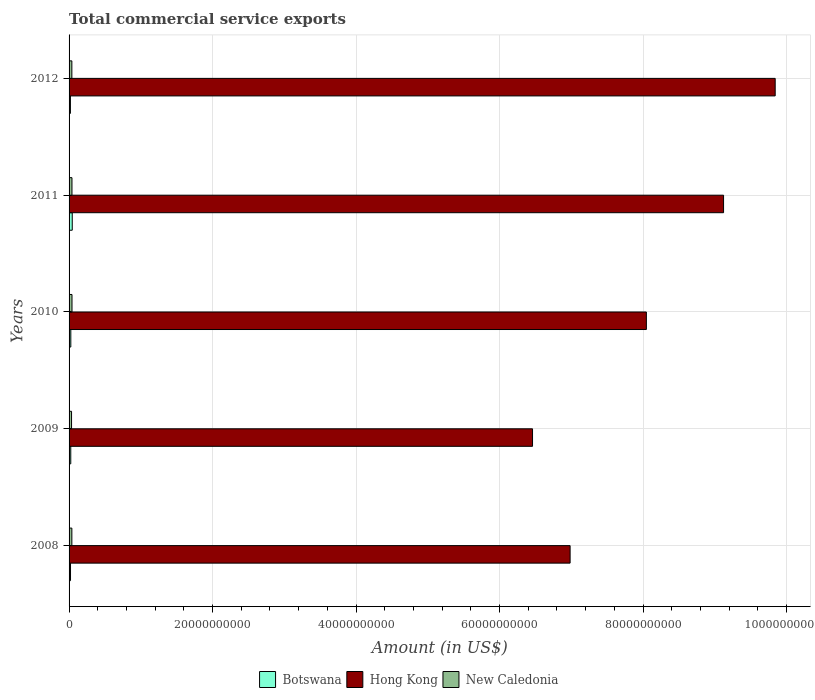How many bars are there on the 4th tick from the top?
Make the answer very short. 3. How many bars are there on the 4th tick from the bottom?
Your response must be concise. 3. What is the label of the 2nd group of bars from the top?
Provide a short and direct response. 2011. In how many cases, is the number of bars for a given year not equal to the number of legend labels?
Make the answer very short. 0. What is the total commercial service exports in Botswana in 2008?
Give a very brief answer. 2.01e+08. Across all years, what is the maximum total commercial service exports in Hong Kong?
Offer a terse response. 9.84e+1. Across all years, what is the minimum total commercial service exports in Botswana?
Your answer should be very brief. 1.89e+08. What is the total total commercial service exports in Botswana in the graph?
Ensure brevity in your answer.  1.31e+09. What is the difference between the total commercial service exports in New Caledonia in 2010 and that in 2012?
Offer a very short reply. 2.11e+07. What is the difference between the total commercial service exports in Botswana in 2010 and the total commercial service exports in Hong Kong in 2008?
Provide a short and direct response. -6.96e+1. What is the average total commercial service exports in Botswana per year?
Your response must be concise. 2.62e+08. In the year 2012, what is the difference between the total commercial service exports in Hong Kong and total commercial service exports in Botswana?
Make the answer very short. 9.82e+1. What is the ratio of the total commercial service exports in Botswana in 2008 to that in 2012?
Keep it short and to the point. 1.06. Is the total commercial service exports in New Caledonia in 2010 less than that in 2012?
Make the answer very short. No. What is the difference between the highest and the second highest total commercial service exports in Hong Kong?
Your answer should be very brief. 7.20e+09. What is the difference between the highest and the lowest total commercial service exports in Hong Kong?
Offer a terse response. 3.38e+1. Is the sum of the total commercial service exports in Hong Kong in 2008 and 2009 greater than the maximum total commercial service exports in New Caledonia across all years?
Offer a terse response. Yes. What does the 2nd bar from the top in 2008 represents?
Your answer should be very brief. Hong Kong. What does the 2nd bar from the bottom in 2009 represents?
Give a very brief answer. Hong Kong. Are all the bars in the graph horizontal?
Give a very brief answer. Yes. How many years are there in the graph?
Make the answer very short. 5. Are the values on the major ticks of X-axis written in scientific E-notation?
Make the answer very short. No. Does the graph contain any zero values?
Offer a very short reply. No. Does the graph contain grids?
Offer a very short reply. Yes. Where does the legend appear in the graph?
Your answer should be compact. Bottom center. How many legend labels are there?
Offer a terse response. 3. How are the legend labels stacked?
Make the answer very short. Horizontal. What is the title of the graph?
Ensure brevity in your answer.  Total commercial service exports. Does "Maldives" appear as one of the legend labels in the graph?
Provide a succinct answer. No. What is the label or title of the X-axis?
Your response must be concise. Amount (in US$). What is the label or title of the Y-axis?
Your answer should be very brief. Years. What is the Amount (in US$) of Botswana in 2008?
Provide a succinct answer. 2.01e+08. What is the Amount (in US$) of Hong Kong in 2008?
Your response must be concise. 6.98e+1. What is the Amount (in US$) in New Caledonia in 2008?
Keep it short and to the point. 3.89e+08. What is the Amount (in US$) of Botswana in 2009?
Your answer should be very brief. 2.36e+08. What is the Amount (in US$) of Hong Kong in 2009?
Keep it short and to the point. 6.46e+1. What is the Amount (in US$) of New Caledonia in 2009?
Ensure brevity in your answer.  3.46e+08. What is the Amount (in US$) of Botswana in 2010?
Offer a very short reply. 2.42e+08. What is the Amount (in US$) of Hong Kong in 2010?
Give a very brief answer. 8.05e+1. What is the Amount (in US$) of New Caledonia in 2010?
Keep it short and to the point. 4.09e+08. What is the Amount (in US$) in Botswana in 2011?
Provide a short and direct response. 4.44e+08. What is the Amount (in US$) of Hong Kong in 2011?
Keep it short and to the point. 9.12e+1. What is the Amount (in US$) of New Caledonia in 2011?
Make the answer very short. 4.04e+08. What is the Amount (in US$) of Botswana in 2012?
Give a very brief answer. 1.89e+08. What is the Amount (in US$) in Hong Kong in 2012?
Your response must be concise. 9.84e+1. What is the Amount (in US$) of New Caledonia in 2012?
Offer a terse response. 3.88e+08. Across all years, what is the maximum Amount (in US$) in Botswana?
Give a very brief answer. 4.44e+08. Across all years, what is the maximum Amount (in US$) in Hong Kong?
Provide a short and direct response. 9.84e+1. Across all years, what is the maximum Amount (in US$) of New Caledonia?
Offer a terse response. 4.09e+08. Across all years, what is the minimum Amount (in US$) of Botswana?
Ensure brevity in your answer.  1.89e+08. Across all years, what is the minimum Amount (in US$) of Hong Kong?
Offer a very short reply. 6.46e+1. Across all years, what is the minimum Amount (in US$) in New Caledonia?
Ensure brevity in your answer.  3.46e+08. What is the total Amount (in US$) of Botswana in the graph?
Your response must be concise. 1.31e+09. What is the total Amount (in US$) of Hong Kong in the graph?
Provide a short and direct response. 4.05e+11. What is the total Amount (in US$) in New Caledonia in the graph?
Your response must be concise. 1.94e+09. What is the difference between the Amount (in US$) in Botswana in 2008 and that in 2009?
Offer a very short reply. -3.49e+07. What is the difference between the Amount (in US$) of Hong Kong in 2008 and that in 2009?
Keep it short and to the point. 5.24e+09. What is the difference between the Amount (in US$) of New Caledonia in 2008 and that in 2009?
Provide a succinct answer. 4.31e+07. What is the difference between the Amount (in US$) of Botswana in 2008 and that in 2010?
Ensure brevity in your answer.  -4.09e+07. What is the difference between the Amount (in US$) in Hong Kong in 2008 and that in 2010?
Ensure brevity in your answer.  -1.06e+1. What is the difference between the Amount (in US$) in New Caledonia in 2008 and that in 2010?
Your response must be concise. -1.97e+07. What is the difference between the Amount (in US$) of Botswana in 2008 and that in 2011?
Keep it short and to the point. -2.43e+08. What is the difference between the Amount (in US$) in Hong Kong in 2008 and that in 2011?
Offer a terse response. -2.14e+1. What is the difference between the Amount (in US$) of New Caledonia in 2008 and that in 2011?
Your answer should be very brief. -1.45e+07. What is the difference between the Amount (in US$) of Botswana in 2008 and that in 2012?
Keep it short and to the point. 1.19e+07. What is the difference between the Amount (in US$) of Hong Kong in 2008 and that in 2012?
Provide a succinct answer. -2.86e+1. What is the difference between the Amount (in US$) in New Caledonia in 2008 and that in 2012?
Offer a terse response. 1.44e+06. What is the difference between the Amount (in US$) of Botswana in 2009 and that in 2010?
Your answer should be very brief. -6.00e+06. What is the difference between the Amount (in US$) in Hong Kong in 2009 and that in 2010?
Provide a short and direct response. -1.59e+1. What is the difference between the Amount (in US$) in New Caledonia in 2009 and that in 2010?
Your answer should be compact. -6.27e+07. What is the difference between the Amount (in US$) of Botswana in 2009 and that in 2011?
Offer a very short reply. -2.08e+08. What is the difference between the Amount (in US$) of Hong Kong in 2009 and that in 2011?
Offer a very short reply. -2.66e+1. What is the difference between the Amount (in US$) in New Caledonia in 2009 and that in 2011?
Keep it short and to the point. -5.76e+07. What is the difference between the Amount (in US$) of Botswana in 2009 and that in 2012?
Ensure brevity in your answer.  4.68e+07. What is the difference between the Amount (in US$) of Hong Kong in 2009 and that in 2012?
Offer a very short reply. -3.38e+1. What is the difference between the Amount (in US$) of New Caledonia in 2009 and that in 2012?
Ensure brevity in your answer.  -4.16e+07. What is the difference between the Amount (in US$) in Botswana in 2010 and that in 2011?
Make the answer very short. -2.02e+08. What is the difference between the Amount (in US$) of Hong Kong in 2010 and that in 2011?
Your response must be concise. -1.08e+1. What is the difference between the Amount (in US$) of New Caledonia in 2010 and that in 2011?
Provide a short and direct response. 5.13e+06. What is the difference between the Amount (in US$) in Botswana in 2010 and that in 2012?
Offer a terse response. 5.28e+07. What is the difference between the Amount (in US$) in Hong Kong in 2010 and that in 2012?
Keep it short and to the point. -1.80e+1. What is the difference between the Amount (in US$) in New Caledonia in 2010 and that in 2012?
Your answer should be very brief. 2.11e+07. What is the difference between the Amount (in US$) in Botswana in 2011 and that in 2012?
Make the answer very short. 2.55e+08. What is the difference between the Amount (in US$) in Hong Kong in 2011 and that in 2012?
Offer a terse response. -7.20e+09. What is the difference between the Amount (in US$) in New Caledonia in 2011 and that in 2012?
Your response must be concise. 1.60e+07. What is the difference between the Amount (in US$) in Botswana in 2008 and the Amount (in US$) in Hong Kong in 2009?
Offer a very short reply. -6.44e+1. What is the difference between the Amount (in US$) in Botswana in 2008 and the Amount (in US$) in New Caledonia in 2009?
Offer a very short reply. -1.45e+08. What is the difference between the Amount (in US$) of Hong Kong in 2008 and the Amount (in US$) of New Caledonia in 2009?
Provide a short and direct response. 6.95e+1. What is the difference between the Amount (in US$) of Botswana in 2008 and the Amount (in US$) of Hong Kong in 2010?
Offer a very short reply. -8.03e+1. What is the difference between the Amount (in US$) in Botswana in 2008 and the Amount (in US$) in New Caledonia in 2010?
Ensure brevity in your answer.  -2.08e+08. What is the difference between the Amount (in US$) in Hong Kong in 2008 and the Amount (in US$) in New Caledonia in 2010?
Your answer should be very brief. 6.94e+1. What is the difference between the Amount (in US$) in Botswana in 2008 and the Amount (in US$) in Hong Kong in 2011?
Your response must be concise. -9.10e+1. What is the difference between the Amount (in US$) in Botswana in 2008 and the Amount (in US$) in New Caledonia in 2011?
Ensure brevity in your answer.  -2.03e+08. What is the difference between the Amount (in US$) in Hong Kong in 2008 and the Amount (in US$) in New Caledonia in 2011?
Your answer should be very brief. 6.94e+1. What is the difference between the Amount (in US$) of Botswana in 2008 and the Amount (in US$) of Hong Kong in 2012?
Provide a short and direct response. -9.82e+1. What is the difference between the Amount (in US$) in Botswana in 2008 and the Amount (in US$) in New Caledonia in 2012?
Ensure brevity in your answer.  -1.87e+08. What is the difference between the Amount (in US$) of Hong Kong in 2008 and the Amount (in US$) of New Caledonia in 2012?
Give a very brief answer. 6.95e+1. What is the difference between the Amount (in US$) of Botswana in 2009 and the Amount (in US$) of Hong Kong in 2010?
Your response must be concise. -8.02e+1. What is the difference between the Amount (in US$) in Botswana in 2009 and the Amount (in US$) in New Caledonia in 2010?
Keep it short and to the point. -1.73e+08. What is the difference between the Amount (in US$) in Hong Kong in 2009 and the Amount (in US$) in New Caledonia in 2010?
Your answer should be compact. 6.42e+1. What is the difference between the Amount (in US$) in Botswana in 2009 and the Amount (in US$) in Hong Kong in 2011?
Your answer should be very brief. -9.10e+1. What is the difference between the Amount (in US$) of Botswana in 2009 and the Amount (in US$) of New Caledonia in 2011?
Provide a short and direct response. -1.68e+08. What is the difference between the Amount (in US$) in Hong Kong in 2009 and the Amount (in US$) in New Caledonia in 2011?
Your answer should be very brief. 6.42e+1. What is the difference between the Amount (in US$) of Botswana in 2009 and the Amount (in US$) of Hong Kong in 2012?
Your response must be concise. -9.82e+1. What is the difference between the Amount (in US$) in Botswana in 2009 and the Amount (in US$) in New Caledonia in 2012?
Provide a succinct answer. -1.52e+08. What is the difference between the Amount (in US$) of Hong Kong in 2009 and the Amount (in US$) of New Caledonia in 2012?
Ensure brevity in your answer.  6.42e+1. What is the difference between the Amount (in US$) in Botswana in 2010 and the Amount (in US$) in Hong Kong in 2011?
Provide a succinct answer. -9.10e+1. What is the difference between the Amount (in US$) in Botswana in 2010 and the Amount (in US$) in New Caledonia in 2011?
Ensure brevity in your answer.  -1.62e+08. What is the difference between the Amount (in US$) of Hong Kong in 2010 and the Amount (in US$) of New Caledonia in 2011?
Your response must be concise. 8.01e+1. What is the difference between the Amount (in US$) in Botswana in 2010 and the Amount (in US$) in Hong Kong in 2012?
Make the answer very short. -9.82e+1. What is the difference between the Amount (in US$) in Botswana in 2010 and the Amount (in US$) in New Caledonia in 2012?
Offer a terse response. -1.46e+08. What is the difference between the Amount (in US$) of Hong Kong in 2010 and the Amount (in US$) of New Caledonia in 2012?
Make the answer very short. 8.01e+1. What is the difference between the Amount (in US$) in Botswana in 2011 and the Amount (in US$) in Hong Kong in 2012?
Keep it short and to the point. -9.80e+1. What is the difference between the Amount (in US$) in Botswana in 2011 and the Amount (in US$) in New Caledonia in 2012?
Provide a short and direct response. 5.63e+07. What is the difference between the Amount (in US$) in Hong Kong in 2011 and the Amount (in US$) in New Caledonia in 2012?
Your answer should be compact. 9.08e+1. What is the average Amount (in US$) of Botswana per year?
Your answer should be compact. 2.62e+08. What is the average Amount (in US$) in Hong Kong per year?
Provide a succinct answer. 8.09e+1. What is the average Amount (in US$) in New Caledonia per year?
Keep it short and to the point. 3.87e+08. In the year 2008, what is the difference between the Amount (in US$) of Botswana and Amount (in US$) of Hong Kong?
Your answer should be compact. -6.96e+1. In the year 2008, what is the difference between the Amount (in US$) of Botswana and Amount (in US$) of New Caledonia?
Your answer should be very brief. -1.88e+08. In the year 2008, what is the difference between the Amount (in US$) in Hong Kong and Amount (in US$) in New Caledonia?
Ensure brevity in your answer.  6.95e+1. In the year 2009, what is the difference between the Amount (in US$) of Botswana and Amount (in US$) of Hong Kong?
Make the answer very short. -6.44e+1. In the year 2009, what is the difference between the Amount (in US$) of Botswana and Amount (in US$) of New Caledonia?
Your answer should be compact. -1.10e+08. In the year 2009, what is the difference between the Amount (in US$) in Hong Kong and Amount (in US$) in New Caledonia?
Offer a terse response. 6.43e+1. In the year 2010, what is the difference between the Amount (in US$) in Botswana and Amount (in US$) in Hong Kong?
Your answer should be very brief. -8.02e+1. In the year 2010, what is the difference between the Amount (in US$) of Botswana and Amount (in US$) of New Caledonia?
Your answer should be compact. -1.67e+08. In the year 2010, what is the difference between the Amount (in US$) of Hong Kong and Amount (in US$) of New Caledonia?
Make the answer very short. 8.01e+1. In the year 2011, what is the difference between the Amount (in US$) in Botswana and Amount (in US$) in Hong Kong?
Your answer should be compact. -9.08e+1. In the year 2011, what is the difference between the Amount (in US$) of Botswana and Amount (in US$) of New Caledonia?
Your response must be concise. 4.04e+07. In the year 2011, what is the difference between the Amount (in US$) of Hong Kong and Amount (in US$) of New Caledonia?
Your answer should be very brief. 9.08e+1. In the year 2012, what is the difference between the Amount (in US$) in Botswana and Amount (in US$) in Hong Kong?
Your answer should be very brief. -9.82e+1. In the year 2012, what is the difference between the Amount (in US$) in Botswana and Amount (in US$) in New Caledonia?
Offer a terse response. -1.99e+08. In the year 2012, what is the difference between the Amount (in US$) of Hong Kong and Amount (in US$) of New Caledonia?
Offer a terse response. 9.80e+1. What is the ratio of the Amount (in US$) in Botswana in 2008 to that in 2009?
Make the answer very short. 0.85. What is the ratio of the Amount (in US$) in Hong Kong in 2008 to that in 2009?
Make the answer very short. 1.08. What is the ratio of the Amount (in US$) of New Caledonia in 2008 to that in 2009?
Your answer should be compact. 1.12. What is the ratio of the Amount (in US$) in Botswana in 2008 to that in 2010?
Give a very brief answer. 0.83. What is the ratio of the Amount (in US$) of Hong Kong in 2008 to that in 2010?
Provide a short and direct response. 0.87. What is the ratio of the Amount (in US$) of New Caledonia in 2008 to that in 2010?
Your answer should be compact. 0.95. What is the ratio of the Amount (in US$) in Botswana in 2008 to that in 2011?
Give a very brief answer. 0.45. What is the ratio of the Amount (in US$) in Hong Kong in 2008 to that in 2011?
Offer a very short reply. 0.77. What is the ratio of the Amount (in US$) in Botswana in 2008 to that in 2012?
Your answer should be compact. 1.06. What is the ratio of the Amount (in US$) in Hong Kong in 2008 to that in 2012?
Provide a succinct answer. 0.71. What is the ratio of the Amount (in US$) of Botswana in 2009 to that in 2010?
Offer a very short reply. 0.98. What is the ratio of the Amount (in US$) of Hong Kong in 2009 to that in 2010?
Your response must be concise. 0.8. What is the ratio of the Amount (in US$) in New Caledonia in 2009 to that in 2010?
Give a very brief answer. 0.85. What is the ratio of the Amount (in US$) of Botswana in 2009 to that in 2011?
Your answer should be compact. 0.53. What is the ratio of the Amount (in US$) of Hong Kong in 2009 to that in 2011?
Offer a very short reply. 0.71. What is the ratio of the Amount (in US$) of New Caledonia in 2009 to that in 2011?
Offer a terse response. 0.86. What is the ratio of the Amount (in US$) of Botswana in 2009 to that in 2012?
Your answer should be very brief. 1.25. What is the ratio of the Amount (in US$) in Hong Kong in 2009 to that in 2012?
Your answer should be very brief. 0.66. What is the ratio of the Amount (in US$) in New Caledonia in 2009 to that in 2012?
Offer a terse response. 0.89. What is the ratio of the Amount (in US$) of Botswana in 2010 to that in 2011?
Your answer should be very brief. 0.54. What is the ratio of the Amount (in US$) in Hong Kong in 2010 to that in 2011?
Ensure brevity in your answer.  0.88. What is the ratio of the Amount (in US$) in New Caledonia in 2010 to that in 2011?
Make the answer very short. 1.01. What is the ratio of the Amount (in US$) in Botswana in 2010 to that in 2012?
Offer a very short reply. 1.28. What is the ratio of the Amount (in US$) in Hong Kong in 2010 to that in 2012?
Provide a short and direct response. 0.82. What is the ratio of the Amount (in US$) of New Caledonia in 2010 to that in 2012?
Offer a terse response. 1.05. What is the ratio of the Amount (in US$) in Botswana in 2011 to that in 2012?
Provide a short and direct response. 2.35. What is the ratio of the Amount (in US$) in Hong Kong in 2011 to that in 2012?
Ensure brevity in your answer.  0.93. What is the ratio of the Amount (in US$) of New Caledonia in 2011 to that in 2012?
Ensure brevity in your answer.  1.04. What is the difference between the highest and the second highest Amount (in US$) of Botswana?
Your answer should be compact. 2.02e+08. What is the difference between the highest and the second highest Amount (in US$) of Hong Kong?
Offer a very short reply. 7.20e+09. What is the difference between the highest and the second highest Amount (in US$) in New Caledonia?
Your response must be concise. 5.13e+06. What is the difference between the highest and the lowest Amount (in US$) in Botswana?
Ensure brevity in your answer.  2.55e+08. What is the difference between the highest and the lowest Amount (in US$) in Hong Kong?
Give a very brief answer. 3.38e+1. What is the difference between the highest and the lowest Amount (in US$) in New Caledonia?
Make the answer very short. 6.27e+07. 